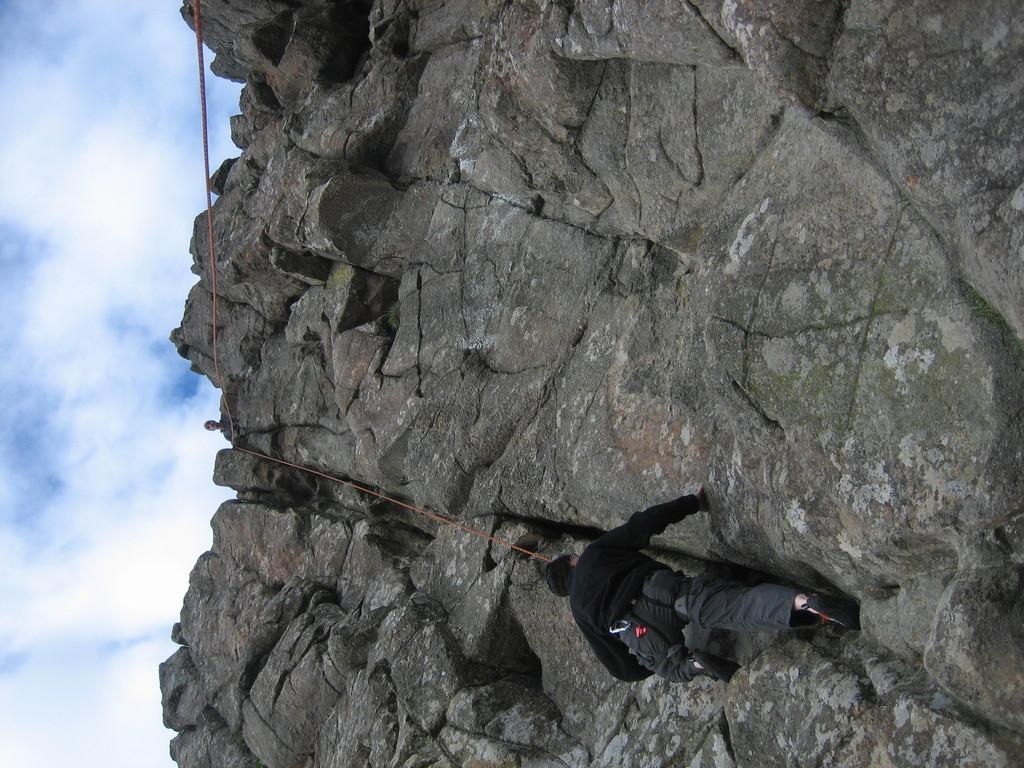Could you give a brief overview of what you see in this image? In this image there is a person trekking the rocky mountain with a rope, on top of the mountain there is another person standing, in the sky there are clouds. 